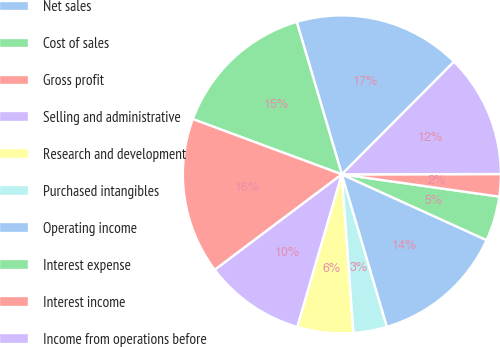<chart> <loc_0><loc_0><loc_500><loc_500><pie_chart><fcel>Net sales<fcel>Cost of sales<fcel>Gross profit<fcel>Selling and administrative<fcel>Research and development<fcel>Purchased intangibles<fcel>Operating income<fcel>Interest expense<fcel>Interest income<fcel>Income from operations before<nl><fcel>17.05%<fcel>14.77%<fcel>15.91%<fcel>10.23%<fcel>5.68%<fcel>3.41%<fcel>13.64%<fcel>4.55%<fcel>2.27%<fcel>12.5%<nl></chart> 